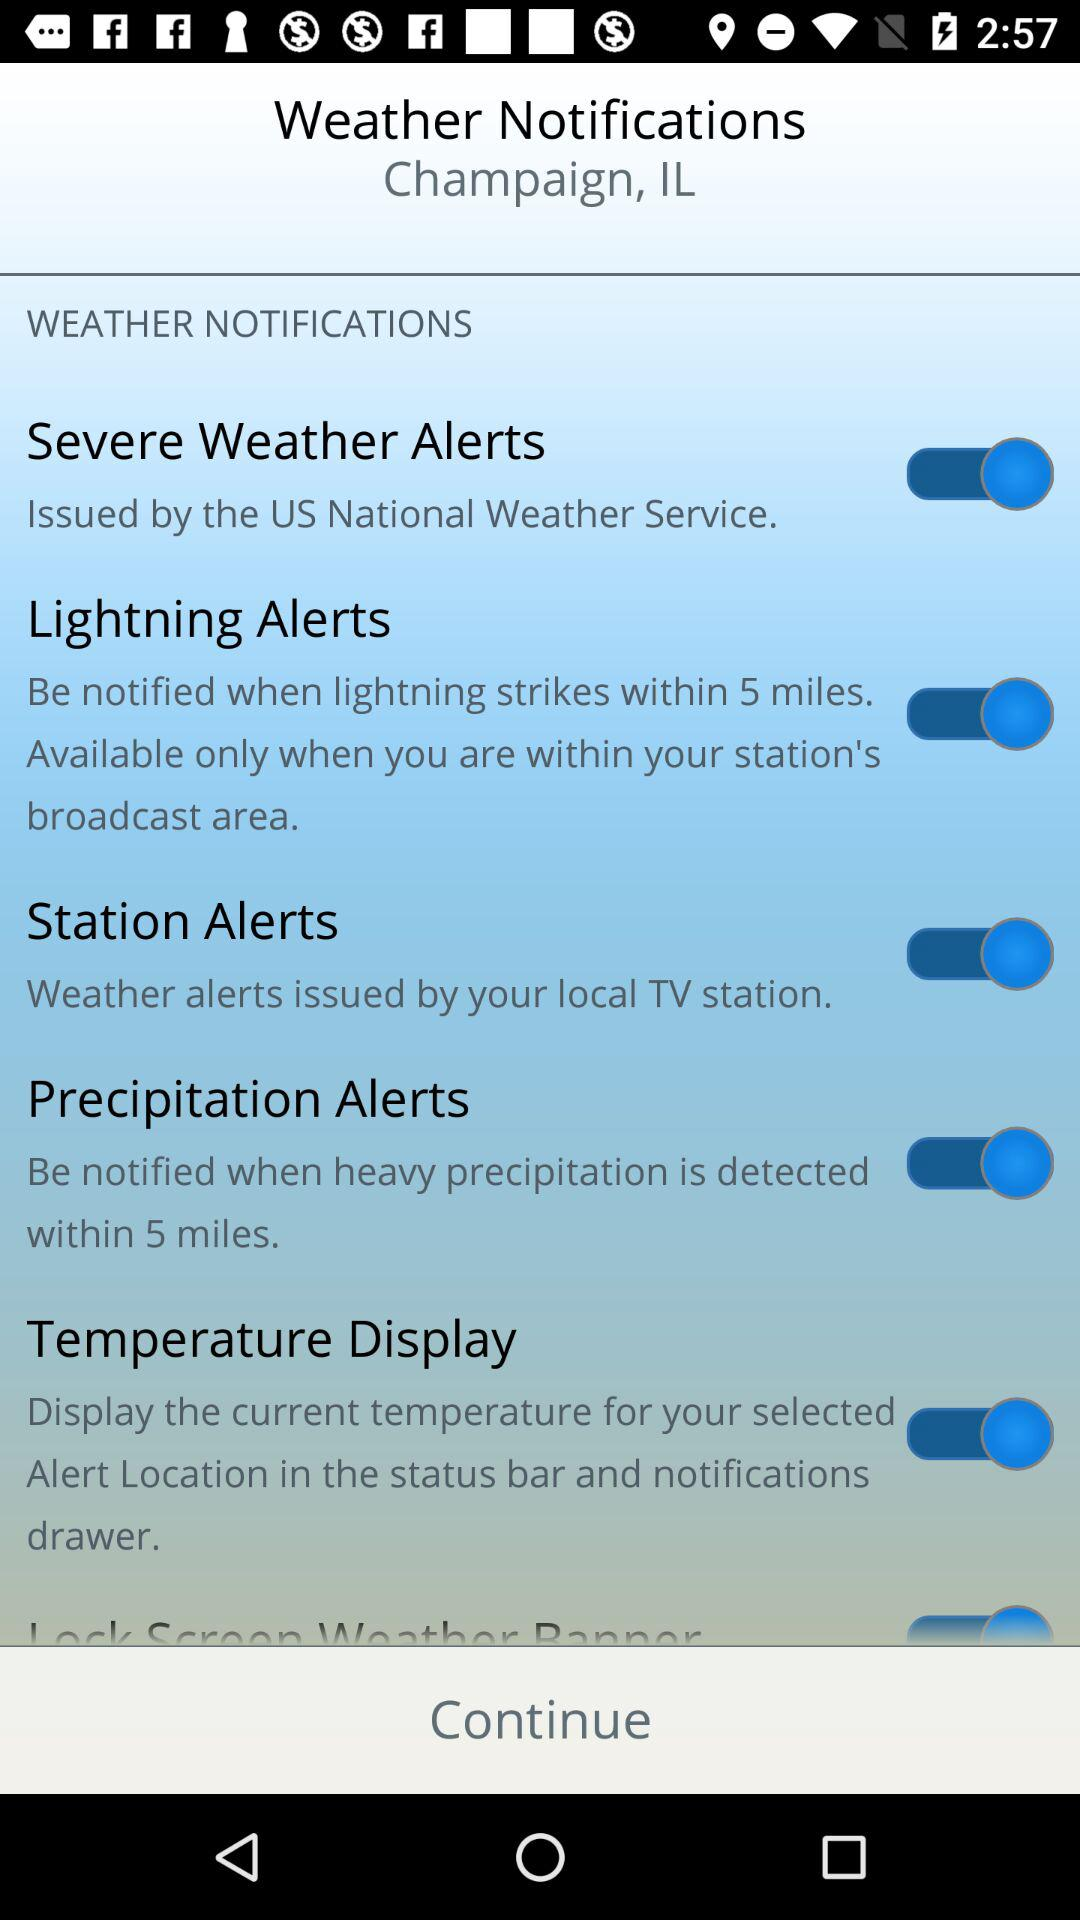What is the status of "Station Alerts"? The status is "on". 